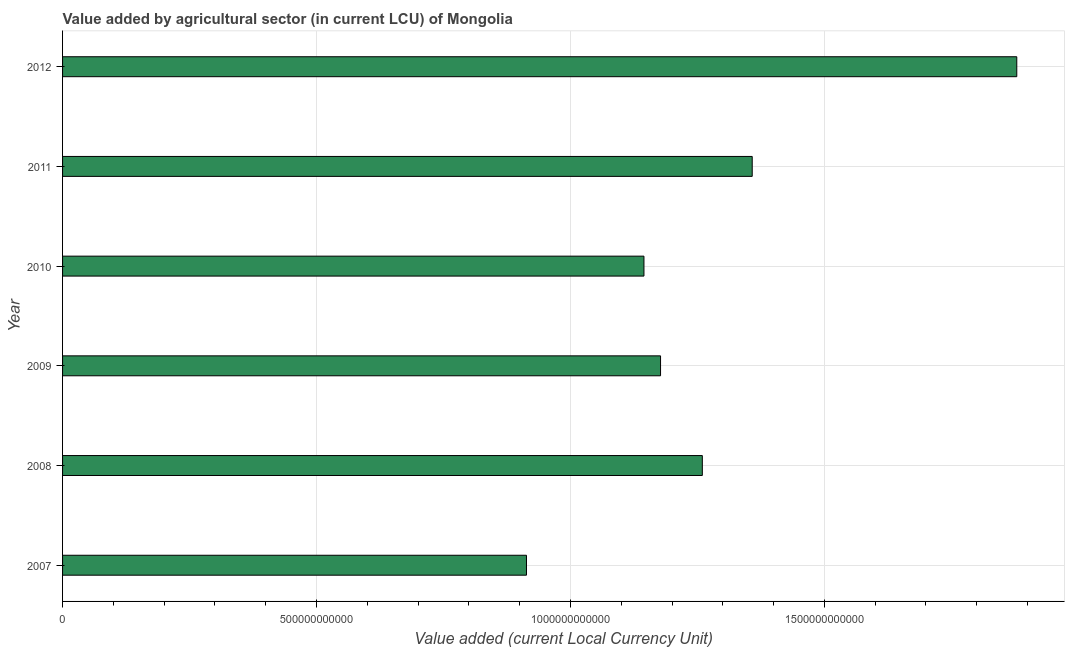Does the graph contain any zero values?
Make the answer very short. No. Does the graph contain grids?
Offer a very short reply. Yes. What is the title of the graph?
Provide a succinct answer. Value added by agricultural sector (in current LCU) of Mongolia. What is the label or title of the X-axis?
Your response must be concise. Value added (current Local Currency Unit). What is the value added by agriculture sector in 2011?
Ensure brevity in your answer.  1.36e+12. Across all years, what is the maximum value added by agriculture sector?
Your answer should be very brief. 1.88e+12. Across all years, what is the minimum value added by agriculture sector?
Provide a short and direct response. 9.13e+11. What is the sum of the value added by agriculture sector?
Make the answer very short. 7.73e+12. What is the difference between the value added by agriculture sector in 2009 and 2012?
Keep it short and to the point. -7.01e+11. What is the average value added by agriculture sector per year?
Offer a terse response. 1.29e+12. What is the median value added by agriculture sector?
Offer a very short reply. 1.22e+12. In how many years, is the value added by agriculture sector greater than 600000000000 LCU?
Offer a very short reply. 6. What is the ratio of the value added by agriculture sector in 2007 to that in 2011?
Offer a terse response. 0.67. Is the value added by agriculture sector in 2007 less than that in 2008?
Offer a terse response. Yes. Is the difference between the value added by agriculture sector in 2008 and 2011 greater than the difference between any two years?
Keep it short and to the point. No. What is the difference between the highest and the second highest value added by agriculture sector?
Offer a terse response. 5.21e+11. What is the difference between the highest and the lowest value added by agriculture sector?
Ensure brevity in your answer.  9.65e+11. How many bars are there?
Provide a short and direct response. 6. What is the difference between two consecutive major ticks on the X-axis?
Give a very brief answer. 5.00e+11. What is the Value added (current Local Currency Unit) in 2007?
Offer a very short reply. 9.13e+11. What is the Value added (current Local Currency Unit) of 2008?
Provide a succinct answer. 1.26e+12. What is the Value added (current Local Currency Unit) in 2009?
Make the answer very short. 1.18e+12. What is the Value added (current Local Currency Unit) in 2010?
Ensure brevity in your answer.  1.14e+12. What is the Value added (current Local Currency Unit) in 2011?
Your response must be concise. 1.36e+12. What is the Value added (current Local Currency Unit) in 2012?
Make the answer very short. 1.88e+12. What is the difference between the Value added (current Local Currency Unit) in 2007 and 2008?
Your answer should be compact. -3.46e+11. What is the difference between the Value added (current Local Currency Unit) in 2007 and 2009?
Provide a succinct answer. -2.64e+11. What is the difference between the Value added (current Local Currency Unit) in 2007 and 2010?
Provide a short and direct response. -2.31e+11. What is the difference between the Value added (current Local Currency Unit) in 2007 and 2011?
Your answer should be very brief. -4.44e+11. What is the difference between the Value added (current Local Currency Unit) in 2007 and 2012?
Provide a succinct answer. -9.65e+11. What is the difference between the Value added (current Local Currency Unit) in 2008 and 2009?
Ensure brevity in your answer.  8.23e+1. What is the difference between the Value added (current Local Currency Unit) in 2008 and 2010?
Offer a very short reply. 1.15e+11. What is the difference between the Value added (current Local Currency Unit) in 2008 and 2011?
Your answer should be very brief. -9.82e+1. What is the difference between the Value added (current Local Currency Unit) in 2008 and 2012?
Your response must be concise. -6.19e+11. What is the difference between the Value added (current Local Currency Unit) in 2009 and 2010?
Make the answer very short. 3.27e+1. What is the difference between the Value added (current Local Currency Unit) in 2009 and 2011?
Your response must be concise. -1.80e+11. What is the difference between the Value added (current Local Currency Unit) in 2009 and 2012?
Ensure brevity in your answer.  -7.01e+11. What is the difference between the Value added (current Local Currency Unit) in 2010 and 2011?
Ensure brevity in your answer.  -2.13e+11. What is the difference between the Value added (current Local Currency Unit) in 2010 and 2012?
Give a very brief answer. -7.34e+11. What is the difference between the Value added (current Local Currency Unit) in 2011 and 2012?
Ensure brevity in your answer.  -5.21e+11. What is the ratio of the Value added (current Local Currency Unit) in 2007 to that in 2008?
Your answer should be compact. 0.72. What is the ratio of the Value added (current Local Currency Unit) in 2007 to that in 2009?
Your answer should be very brief. 0.78. What is the ratio of the Value added (current Local Currency Unit) in 2007 to that in 2010?
Keep it short and to the point. 0.8. What is the ratio of the Value added (current Local Currency Unit) in 2007 to that in 2011?
Make the answer very short. 0.67. What is the ratio of the Value added (current Local Currency Unit) in 2007 to that in 2012?
Ensure brevity in your answer.  0.49. What is the ratio of the Value added (current Local Currency Unit) in 2008 to that in 2009?
Give a very brief answer. 1.07. What is the ratio of the Value added (current Local Currency Unit) in 2008 to that in 2011?
Your response must be concise. 0.93. What is the ratio of the Value added (current Local Currency Unit) in 2008 to that in 2012?
Your answer should be compact. 0.67. What is the ratio of the Value added (current Local Currency Unit) in 2009 to that in 2011?
Your answer should be very brief. 0.87. What is the ratio of the Value added (current Local Currency Unit) in 2009 to that in 2012?
Your response must be concise. 0.63. What is the ratio of the Value added (current Local Currency Unit) in 2010 to that in 2011?
Give a very brief answer. 0.84. What is the ratio of the Value added (current Local Currency Unit) in 2010 to that in 2012?
Ensure brevity in your answer.  0.61. What is the ratio of the Value added (current Local Currency Unit) in 2011 to that in 2012?
Your response must be concise. 0.72. 